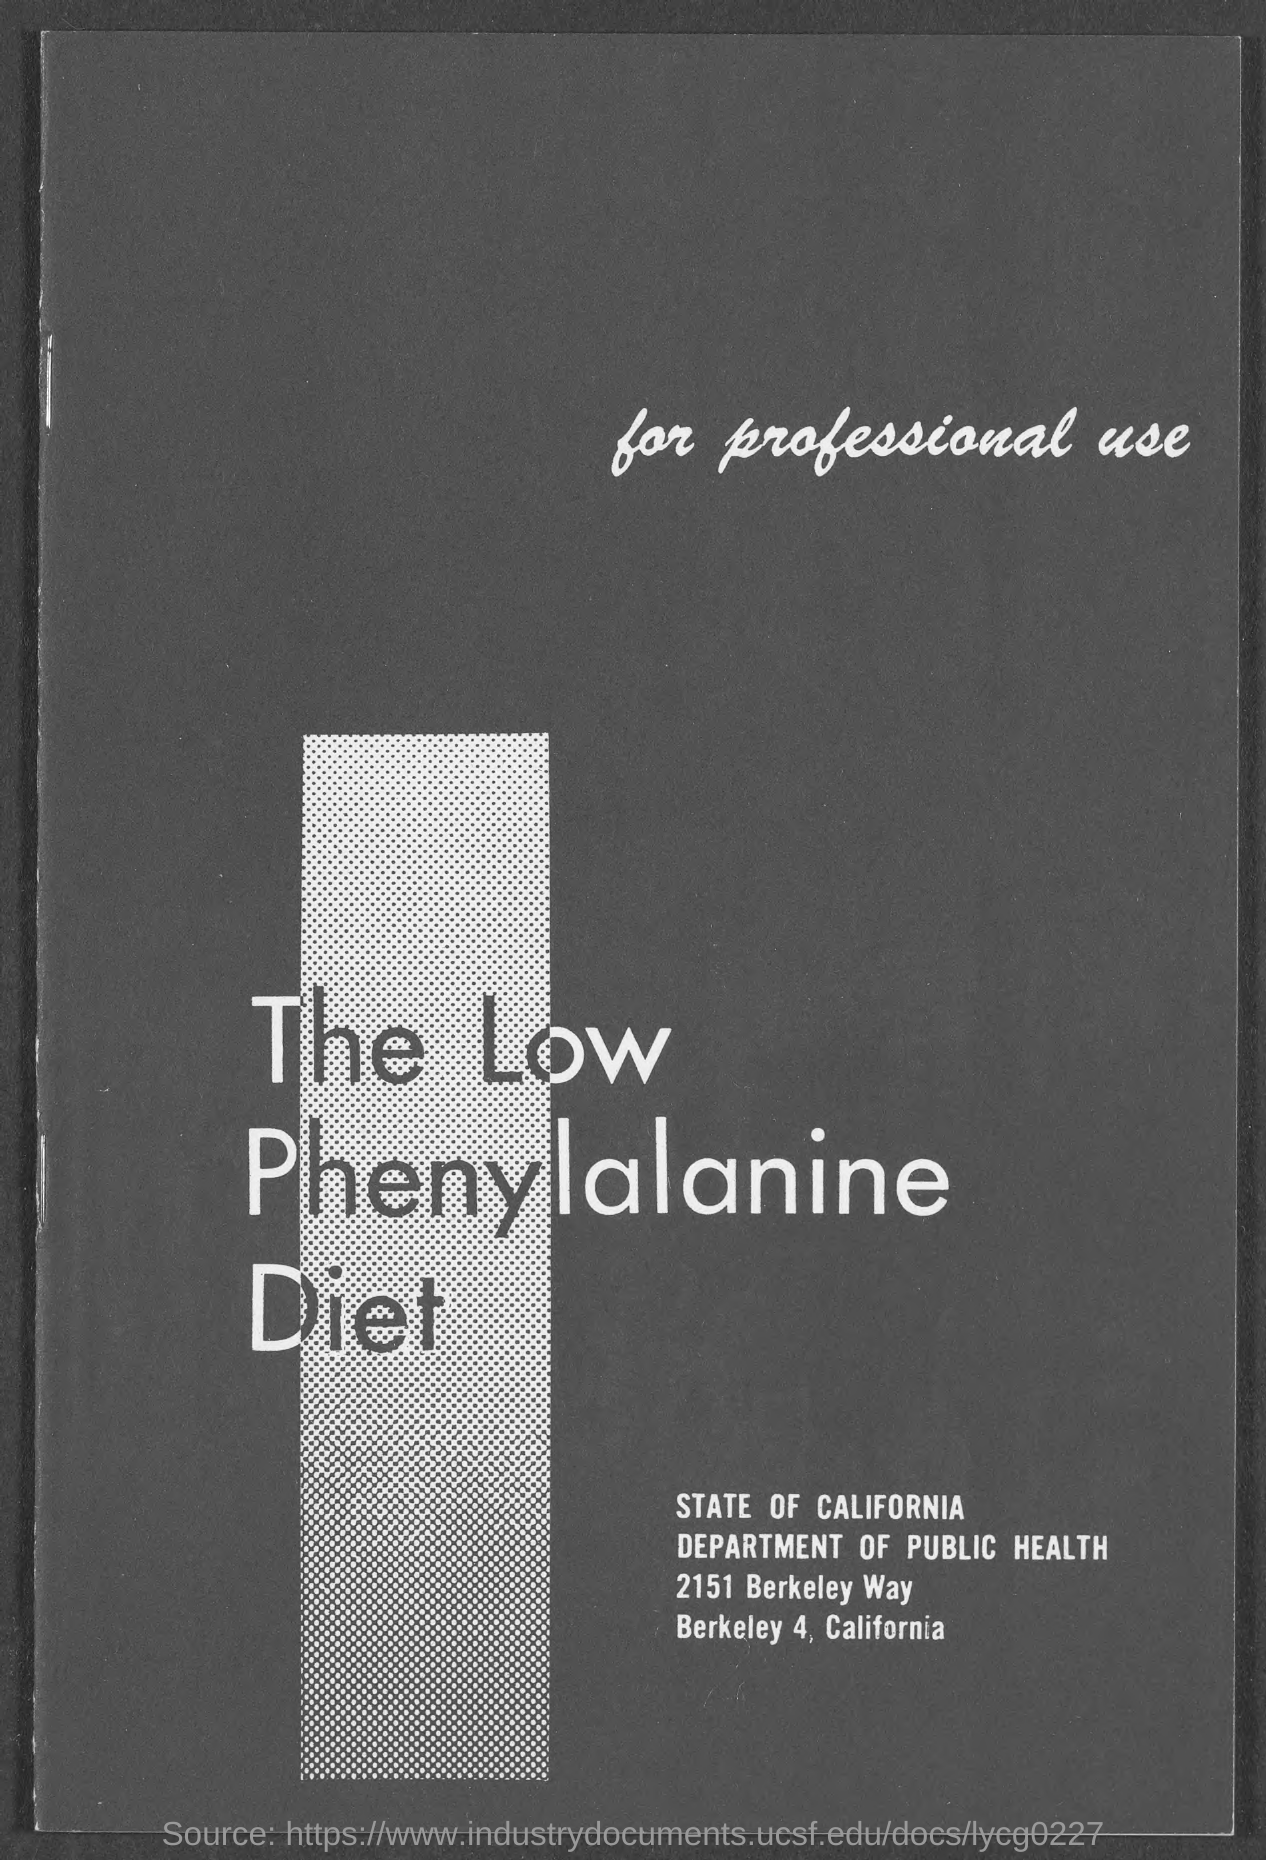Mention a couple of crucial points in this snapshot. The Department of Public Health is mentioned. The title of the book is "The Low Phenylalanine Diet. 